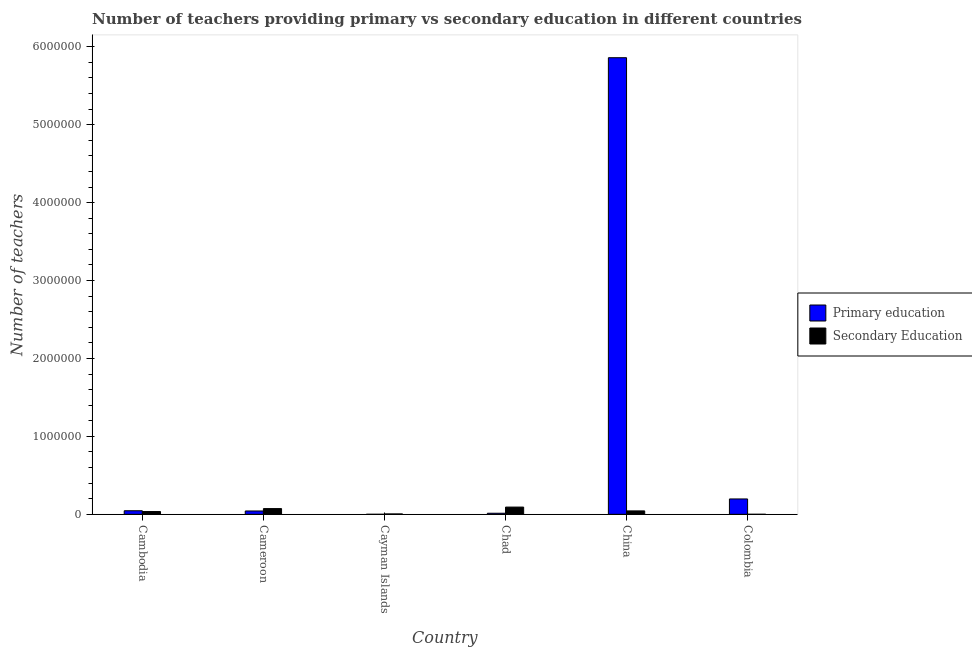How many bars are there on the 2nd tick from the left?
Your answer should be compact. 2. What is the label of the 6th group of bars from the left?
Your answer should be very brief. Colombia. In how many cases, is the number of bars for a given country not equal to the number of legend labels?
Keep it short and to the point. 0. What is the number of primary teachers in Colombia?
Keep it short and to the point. 1.97e+05. Across all countries, what is the maximum number of secondary teachers?
Make the answer very short. 9.29e+04. Across all countries, what is the minimum number of secondary teachers?
Keep it short and to the point. 374. In which country was the number of secondary teachers maximum?
Your response must be concise. Chad. In which country was the number of primary teachers minimum?
Keep it short and to the point. Cayman Islands. What is the total number of primary teachers in the graph?
Your answer should be very brief. 6.16e+06. What is the difference between the number of primary teachers in Cambodia and that in Colombia?
Provide a succinct answer. -1.51e+05. What is the difference between the number of primary teachers in Cayman Islands and the number of secondary teachers in Colombia?
Your answer should be compact. -140. What is the average number of secondary teachers per country?
Your answer should be very brief. 4.19e+04. What is the difference between the number of primary teachers and number of secondary teachers in Colombia?
Your response must be concise. 1.97e+05. What is the ratio of the number of secondary teachers in Cayman Islands to that in China?
Offer a terse response. 0.11. Is the number of secondary teachers in China less than that in Colombia?
Provide a succinct answer. No. Is the difference between the number of secondary teachers in Cameroon and Chad greater than the difference between the number of primary teachers in Cameroon and Chad?
Offer a very short reply. No. What is the difference between the highest and the second highest number of primary teachers?
Your response must be concise. 5.66e+06. What is the difference between the highest and the lowest number of primary teachers?
Your answer should be very brief. 5.86e+06. What does the 1st bar from the left in Colombia represents?
Provide a succinct answer. Primary education. What does the 1st bar from the right in Cambodia represents?
Ensure brevity in your answer.  Secondary Education. How many bars are there?
Your answer should be very brief. 12. Are all the bars in the graph horizontal?
Provide a short and direct response. No. How many countries are there in the graph?
Ensure brevity in your answer.  6. What is the difference between two consecutive major ticks on the Y-axis?
Your response must be concise. 1.00e+06. Does the graph contain grids?
Keep it short and to the point. No. How are the legend labels stacked?
Offer a terse response. Vertical. What is the title of the graph?
Keep it short and to the point. Number of teachers providing primary vs secondary education in different countries. Does "Young" appear as one of the legend labels in the graph?
Offer a very short reply. No. What is the label or title of the Y-axis?
Give a very brief answer. Number of teachers. What is the Number of teachers in Primary education in Cambodia?
Provide a short and direct response. 4.59e+04. What is the Number of teachers in Secondary Education in Cambodia?
Keep it short and to the point. 3.58e+04. What is the Number of teachers of Primary education in Cameroon?
Ensure brevity in your answer.  4.29e+04. What is the Number of teachers in Secondary Education in Cameroon?
Keep it short and to the point. 7.36e+04. What is the Number of teachers of Primary education in Cayman Islands?
Keep it short and to the point. 234. What is the Number of teachers of Secondary Education in Cayman Islands?
Offer a very short reply. 5031. What is the Number of teachers in Primary education in Chad?
Your answer should be compact. 1.38e+04. What is the Number of teachers of Secondary Education in Chad?
Offer a very short reply. 9.29e+04. What is the Number of teachers in Primary education in China?
Provide a succinct answer. 5.86e+06. What is the Number of teachers of Secondary Education in China?
Ensure brevity in your answer.  4.39e+04. What is the Number of teachers of Primary education in Colombia?
Provide a succinct answer. 1.97e+05. What is the Number of teachers of Secondary Education in Colombia?
Provide a short and direct response. 374. Across all countries, what is the maximum Number of teachers in Primary education?
Your response must be concise. 5.86e+06. Across all countries, what is the maximum Number of teachers in Secondary Education?
Make the answer very short. 9.29e+04. Across all countries, what is the minimum Number of teachers of Primary education?
Provide a short and direct response. 234. Across all countries, what is the minimum Number of teachers of Secondary Education?
Your answer should be compact. 374. What is the total Number of teachers in Primary education in the graph?
Your answer should be compact. 6.16e+06. What is the total Number of teachers of Secondary Education in the graph?
Make the answer very short. 2.52e+05. What is the difference between the Number of teachers of Primary education in Cambodia and that in Cameroon?
Give a very brief answer. 3041. What is the difference between the Number of teachers in Secondary Education in Cambodia and that in Cameroon?
Your answer should be compact. -3.79e+04. What is the difference between the Number of teachers in Primary education in Cambodia and that in Cayman Islands?
Your answer should be compact. 4.57e+04. What is the difference between the Number of teachers in Secondary Education in Cambodia and that in Cayman Islands?
Make the answer very short. 3.07e+04. What is the difference between the Number of teachers in Primary education in Cambodia and that in Chad?
Offer a terse response. 3.21e+04. What is the difference between the Number of teachers in Secondary Education in Cambodia and that in Chad?
Give a very brief answer. -5.72e+04. What is the difference between the Number of teachers in Primary education in Cambodia and that in China?
Keep it short and to the point. -5.81e+06. What is the difference between the Number of teachers of Secondary Education in Cambodia and that in China?
Provide a short and direct response. -8156. What is the difference between the Number of teachers in Primary education in Cambodia and that in Colombia?
Your answer should be compact. -1.51e+05. What is the difference between the Number of teachers of Secondary Education in Cambodia and that in Colombia?
Provide a short and direct response. 3.54e+04. What is the difference between the Number of teachers of Primary education in Cameroon and that in Cayman Islands?
Keep it short and to the point. 4.26e+04. What is the difference between the Number of teachers of Secondary Education in Cameroon and that in Cayman Islands?
Provide a short and direct response. 6.86e+04. What is the difference between the Number of teachers of Primary education in Cameroon and that in Chad?
Offer a very short reply. 2.91e+04. What is the difference between the Number of teachers of Secondary Education in Cameroon and that in Chad?
Your answer should be compact. -1.93e+04. What is the difference between the Number of teachers in Primary education in Cameroon and that in China?
Your answer should be very brief. -5.82e+06. What is the difference between the Number of teachers of Secondary Education in Cameroon and that in China?
Your answer should be compact. 2.97e+04. What is the difference between the Number of teachers of Primary education in Cameroon and that in Colombia?
Offer a very short reply. -1.54e+05. What is the difference between the Number of teachers of Secondary Education in Cameroon and that in Colombia?
Offer a terse response. 7.33e+04. What is the difference between the Number of teachers of Primary education in Cayman Islands and that in Chad?
Your answer should be very brief. -1.36e+04. What is the difference between the Number of teachers in Secondary Education in Cayman Islands and that in Chad?
Keep it short and to the point. -8.79e+04. What is the difference between the Number of teachers of Primary education in Cayman Islands and that in China?
Your answer should be compact. -5.86e+06. What is the difference between the Number of teachers in Secondary Education in Cayman Islands and that in China?
Offer a very short reply. -3.89e+04. What is the difference between the Number of teachers in Primary education in Cayman Islands and that in Colombia?
Your answer should be compact. -1.97e+05. What is the difference between the Number of teachers of Secondary Education in Cayman Islands and that in Colombia?
Your answer should be very brief. 4657. What is the difference between the Number of teachers of Primary education in Chad and that in China?
Provide a succinct answer. -5.85e+06. What is the difference between the Number of teachers in Secondary Education in Chad and that in China?
Make the answer very short. 4.90e+04. What is the difference between the Number of teachers in Primary education in Chad and that in Colombia?
Your answer should be compact. -1.83e+05. What is the difference between the Number of teachers in Secondary Education in Chad and that in Colombia?
Give a very brief answer. 9.26e+04. What is the difference between the Number of teachers in Primary education in China and that in Colombia?
Ensure brevity in your answer.  5.66e+06. What is the difference between the Number of teachers of Secondary Education in China and that in Colombia?
Provide a short and direct response. 4.35e+04. What is the difference between the Number of teachers of Primary education in Cambodia and the Number of teachers of Secondary Education in Cameroon?
Keep it short and to the point. -2.77e+04. What is the difference between the Number of teachers in Primary education in Cambodia and the Number of teachers in Secondary Education in Cayman Islands?
Provide a succinct answer. 4.09e+04. What is the difference between the Number of teachers in Primary education in Cambodia and the Number of teachers in Secondary Education in Chad?
Your response must be concise. -4.70e+04. What is the difference between the Number of teachers of Primary education in Cambodia and the Number of teachers of Secondary Education in China?
Provide a short and direct response. 1993. What is the difference between the Number of teachers in Primary education in Cambodia and the Number of teachers in Secondary Education in Colombia?
Provide a succinct answer. 4.55e+04. What is the difference between the Number of teachers of Primary education in Cameroon and the Number of teachers of Secondary Education in Cayman Islands?
Keep it short and to the point. 3.78e+04. What is the difference between the Number of teachers in Primary education in Cameroon and the Number of teachers in Secondary Education in Chad?
Your answer should be very brief. -5.01e+04. What is the difference between the Number of teachers of Primary education in Cameroon and the Number of teachers of Secondary Education in China?
Provide a short and direct response. -1048. What is the difference between the Number of teachers in Primary education in Cameroon and the Number of teachers in Secondary Education in Colombia?
Your response must be concise. 4.25e+04. What is the difference between the Number of teachers of Primary education in Cayman Islands and the Number of teachers of Secondary Education in Chad?
Ensure brevity in your answer.  -9.27e+04. What is the difference between the Number of teachers of Primary education in Cayman Islands and the Number of teachers of Secondary Education in China?
Keep it short and to the point. -4.37e+04. What is the difference between the Number of teachers in Primary education in Cayman Islands and the Number of teachers in Secondary Education in Colombia?
Offer a very short reply. -140. What is the difference between the Number of teachers in Primary education in Chad and the Number of teachers in Secondary Education in China?
Your answer should be very brief. -3.01e+04. What is the difference between the Number of teachers in Primary education in Chad and the Number of teachers in Secondary Education in Colombia?
Your response must be concise. 1.34e+04. What is the difference between the Number of teachers of Primary education in China and the Number of teachers of Secondary Education in Colombia?
Ensure brevity in your answer.  5.86e+06. What is the average Number of teachers in Primary education per country?
Offer a very short reply. 1.03e+06. What is the average Number of teachers of Secondary Education per country?
Ensure brevity in your answer.  4.19e+04. What is the difference between the Number of teachers of Primary education and Number of teachers of Secondary Education in Cambodia?
Give a very brief answer. 1.01e+04. What is the difference between the Number of teachers in Primary education and Number of teachers in Secondary Education in Cameroon?
Offer a very short reply. -3.08e+04. What is the difference between the Number of teachers in Primary education and Number of teachers in Secondary Education in Cayman Islands?
Offer a very short reply. -4797. What is the difference between the Number of teachers in Primary education and Number of teachers in Secondary Education in Chad?
Ensure brevity in your answer.  -7.91e+04. What is the difference between the Number of teachers of Primary education and Number of teachers of Secondary Education in China?
Your response must be concise. 5.82e+06. What is the difference between the Number of teachers in Primary education and Number of teachers in Secondary Education in Colombia?
Provide a succinct answer. 1.97e+05. What is the ratio of the Number of teachers in Primary education in Cambodia to that in Cameroon?
Provide a succinct answer. 1.07. What is the ratio of the Number of teachers of Secondary Education in Cambodia to that in Cameroon?
Your answer should be very brief. 0.49. What is the ratio of the Number of teachers of Primary education in Cambodia to that in Cayman Islands?
Your answer should be compact. 196.21. What is the ratio of the Number of teachers of Secondary Education in Cambodia to that in Cayman Islands?
Provide a succinct answer. 7.11. What is the ratio of the Number of teachers of Primary education in Cambodia to that in Chad?
Provide a short and direct response. 3.32. What is the ratio of the Number of teachers of Secondary Education in Cambodia to that in Chad?
Offer a terse response. 0.38. What is the ratio of the Number of teachers in Primary education in Cambodia to that in China?
Offer a very short reply. 0.01. What is the ratio of the Number of teachers of Secondary Education in Cambodia to that in China?
Provide a short and direct response. 0.81. What is the ratio of the Number of teachers in Primary education in Cambodia to that in Colombia?
Ensure brevity in your answer.  0.23. What is the ratio of the Number of teachers of Secondary Education in Cambodia to that in Colombia?
Your answer should be compact. 95.63. What is the ratio of the Number of teachers in Primary education in Cameroon to that in Cayman Islands?
Keep it short and to the point. 183.22. What is the ratio of the Number of teachers of Secondary Education in Cameroon to that in Cayman Islands?
Give a very brief answer. 14.63. What is the ratio of the Number of teachers of Primary education in Cameroon to that in Chad?
Provide a short and direct response. 3.1. What is the ratio of the Number of teachers of Secondary Education in Cameroon to that in Chad?
Give a very brief answer. 0.79. What is the ratio of the Number of teachers in Primary education in Cameroon to that in China?
Give a very brief answer. 0.01. What is the ratio of the Number of teachers in Secondary Education in Cameroon to that in China?
Provide a succinct answer. 1.68. What is the ratio of the Number of teachers in Primary education in Cameroon to that in Colombia?
Give a very brief answer. 0.22. What is the ratio of the Number of teachers in Secondary Education in Cameroon to that in Colombia?
Ensure brevity in your answer.  196.86. What is the ratio of the Number of teachers in Primary education in Cayman Islands to that in Chad?
Provide a succinct answer. 0.02. What is the ratio of the Number of teachers of Secondary Education in Cayman Islands to that in Chad?
Your answer should be very brief. 0.05. What is the ratio of the Number of teachers in Primary education in Cayman Islands to that in China?
Offer a very short reply. 0. What is the ratio of the Number of teachers in Secondary Education in Cayman Islands to that in China?
Your answer should be very brief. 0.11. What is the ratio of the Number of teachers of Primary education in Cayman Islands to that in Colombia?
Keep it short and to the point. 0. What is the ratio of the Number of teachers in Secondary Education in Cayman Islands to that in Colombia?
Ensure brevity in your answer.  13.45. What is the ratio of the Number of teachers of Primary education in Chad to that in China?
Offer a very short reply. 0. What is the ratio of the Number of teachers in Secondary Education in Chad to that in China?
Your response must be concise. 2.12. What is the ratio of the Number of teachers in Primary education in Chad to that in Colombia?
Give a very brief answer. 0.07. What is the ratio of the Number of teachers of Secondary Education in Chad to that in Colombia?
Your answer should be very brief. 248.46. What is the ratio of the Number of teachers of Primary education in China to that in Colombia?
Make the answer very short. 29.71. What is the ratio of the Number of teachers in Secondary Education in China to that in Colombia?
Make the answer very short. 117.44. What is the difference between the highest and the second highest Number of teachers in Primary education?
Make the answer very short. 5.66e+06. What is the difference between the highest and the second highest Number of teachers in Secondary Education?
Make the answer very short. 1.93e+04. What is the difference between the highest and the lowest Number of teachers of Primary education?
Provide a short and direct response. 5.86e+06. What is the difference between the highest and the lowest Number of teachers of Secondary Education?
Provide a short and direct response. 9.26e+04. 